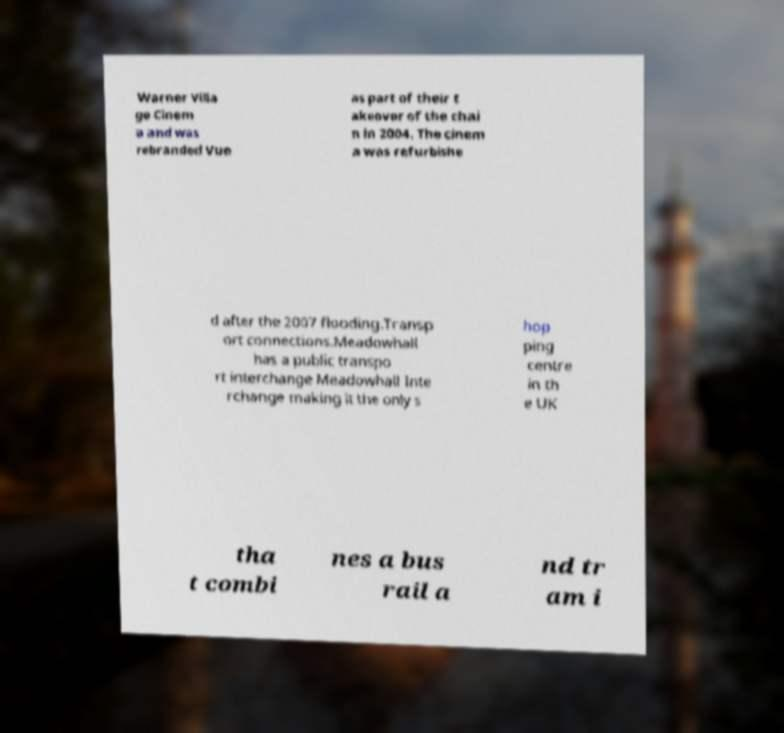Could you extract and type out the text from this image? Warner Villa ge Cinem a and was rebranded Vue as part of their t akeover of the chai n in 2004. The cinem a was refurbishe d after the 2007 flooding.Transp ort connections.Meadowhall has a public transpo rt interchange Meadowhall Inte rchange making it the only s hop ping centre in th e UK tha t combi nes a bus rail a nd tr am i 